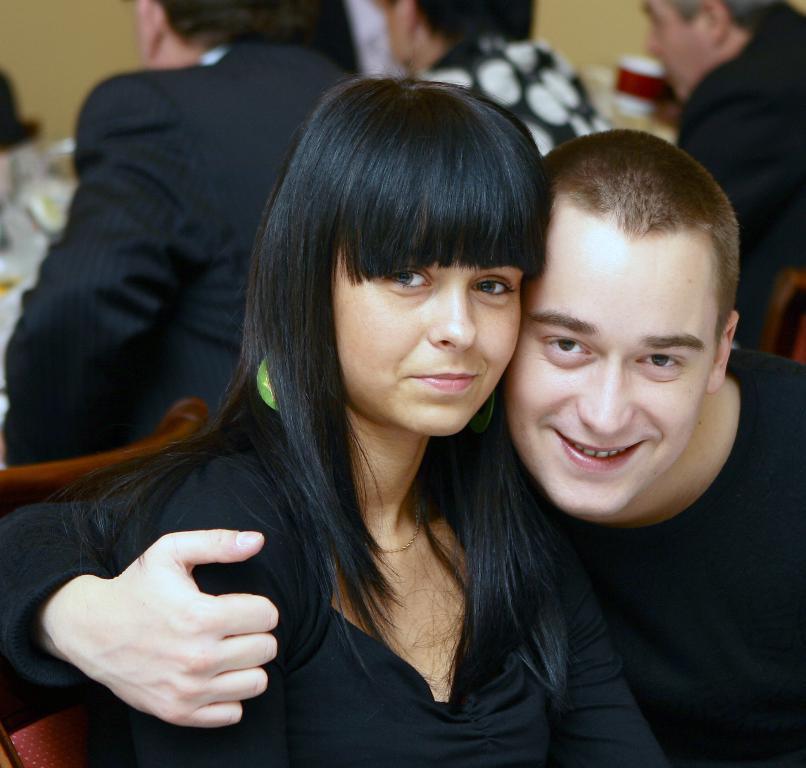In one or two sentences, can you explain what this image depicts? In this picture we can see some people are sitting, two persons in the front are smiling, in the background we can see a wall, a person at the right top of the picture is holding a cup. 